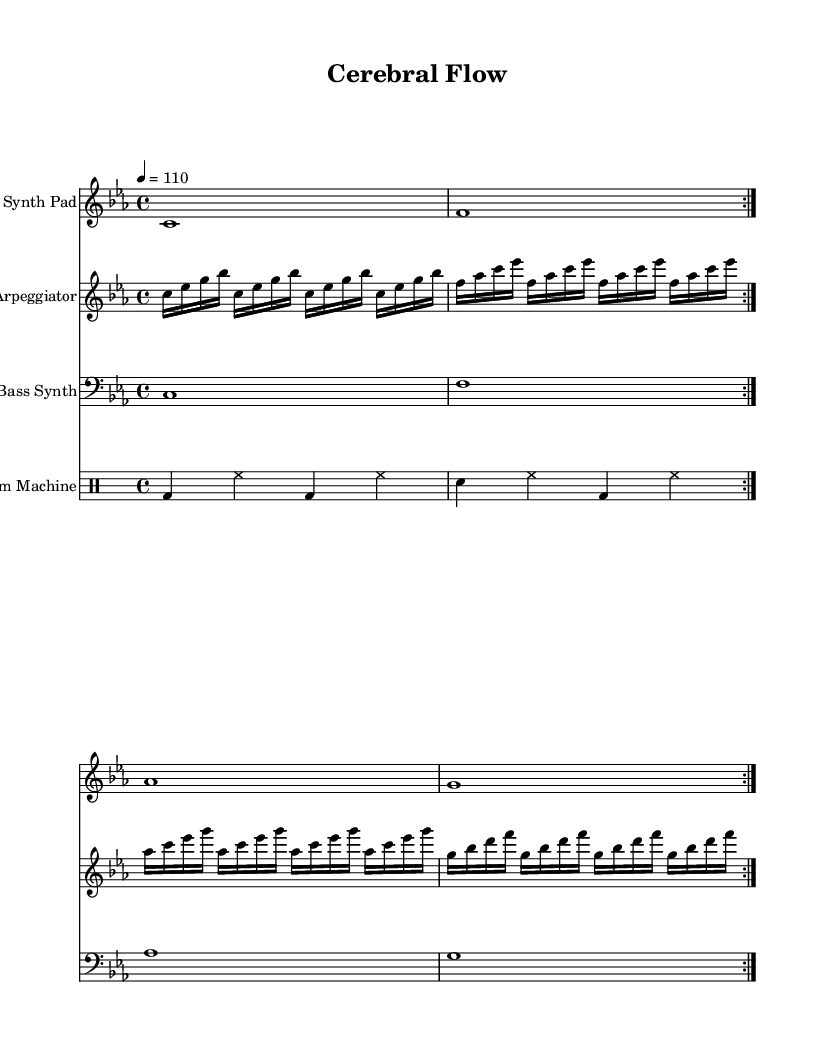What is the key signature of this music? The key signature indicates C minor, which includes three flats (B flat, E flat, and A flat). This can be identified by looking at the key signature at the beginning of the staff.
Answer: C minor What is the time signature of this music? The time signature is 4/4, which means there are four beats in each measure and the quarter note receives one beat. This is evident from the notation displayed after the clef and key signature.
Answer: 4/4 What is the tempo marking for this piece? The tempo marking is given as a quarter note equals 110 beats per minute, which is indicated at the start of the score. This sets the speed for the performance of the piece.
Answer: 110 How many volta repeats are indicated for the synth pad section? There are two volta repeats for the synth pad section, as marked by the repeat signs and the word "volta" at the beginning of the corresponding measure.
Answer: 2 What is the role of the arpeggiator in this piece? The arpeggiator plays a rapid sequence of notes in a specific pattern that emphasizes the harmonic structure. This is shown in the notation where a series of individual notes are grouped in a rhythmic pattern, distinct from the synth pad and other layers.
Answer: Harmonic support What instruments are used in this score? The score features four instruments: Synth Pad, Arpeggiator, Bass Synth, and Drum Machine. These are labeled at the beginning of each staff and indicate the different voices contributing to the overall sound of the piece.
Answer: Synth Pad, Arpeggiator, Bass Synth, Drum Machine What is the primary rhythmic figure in the drum machine section? The primary rhythmic figure in the drum machine section consists of a kick drum pattern followed by hi-hat and snare hits. This characteristic can be observed in the consistent pattern of notes in the drum staff.
Answer: Kick drum pattern 